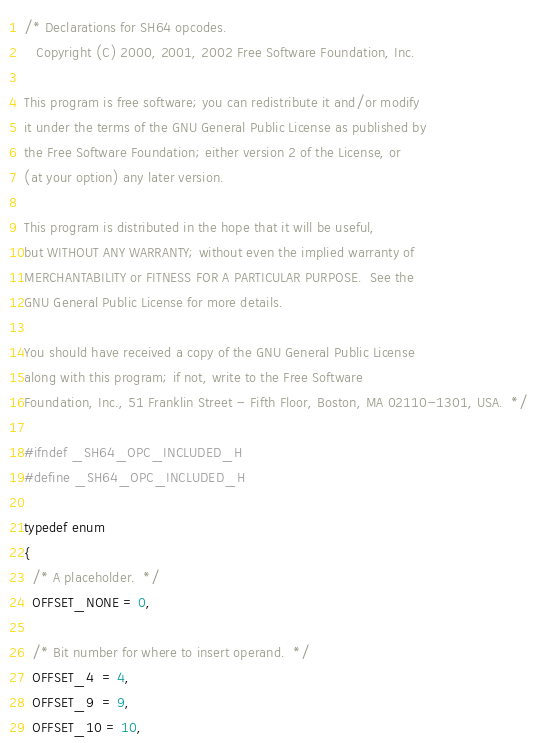<code> <loc_0><loc_0><loc_500><loc_500><_C_>/* Declarations for SH64 opcodes.
   Copyright (C) 2000, 2001, 2002 Free Software Foundation, Inc.

This program is free software; you can redistribute it and/or modify
it under the terms of the GNU General Public License as published by
the Free Software Foundation; either version 2 of the License, or
(at your option) any later version.

This program is distributed in the hope that it will be useful,
but WITHOUT ANY WARRANTY; without even the implied warranty of
MERCHANTABILITY or FITNESS FOR A PARTICULAR PURPOSE.  See the
GNU General Public License for more details.

You should have received a copy of the GNU General Public License
along with this program; if not, write to the Free Software
Foundation, Inc., 51 Franklin Street - Fifth Floor, Boston, MA 02110-1301, USA.  */

#ifndef _SH64_OPC_INCLUDED_H
#define _SH64_OPC_INCLUDED_H

typedef enum
{
  /* A placeholder.  */
  OFFSET_NONE = 0,

  /* Bit number for where to insert operand.  */
  OFFSET_4  = 4,
  OFFSET_9  = 9,
  OFFSET_10 = 10,</code> 